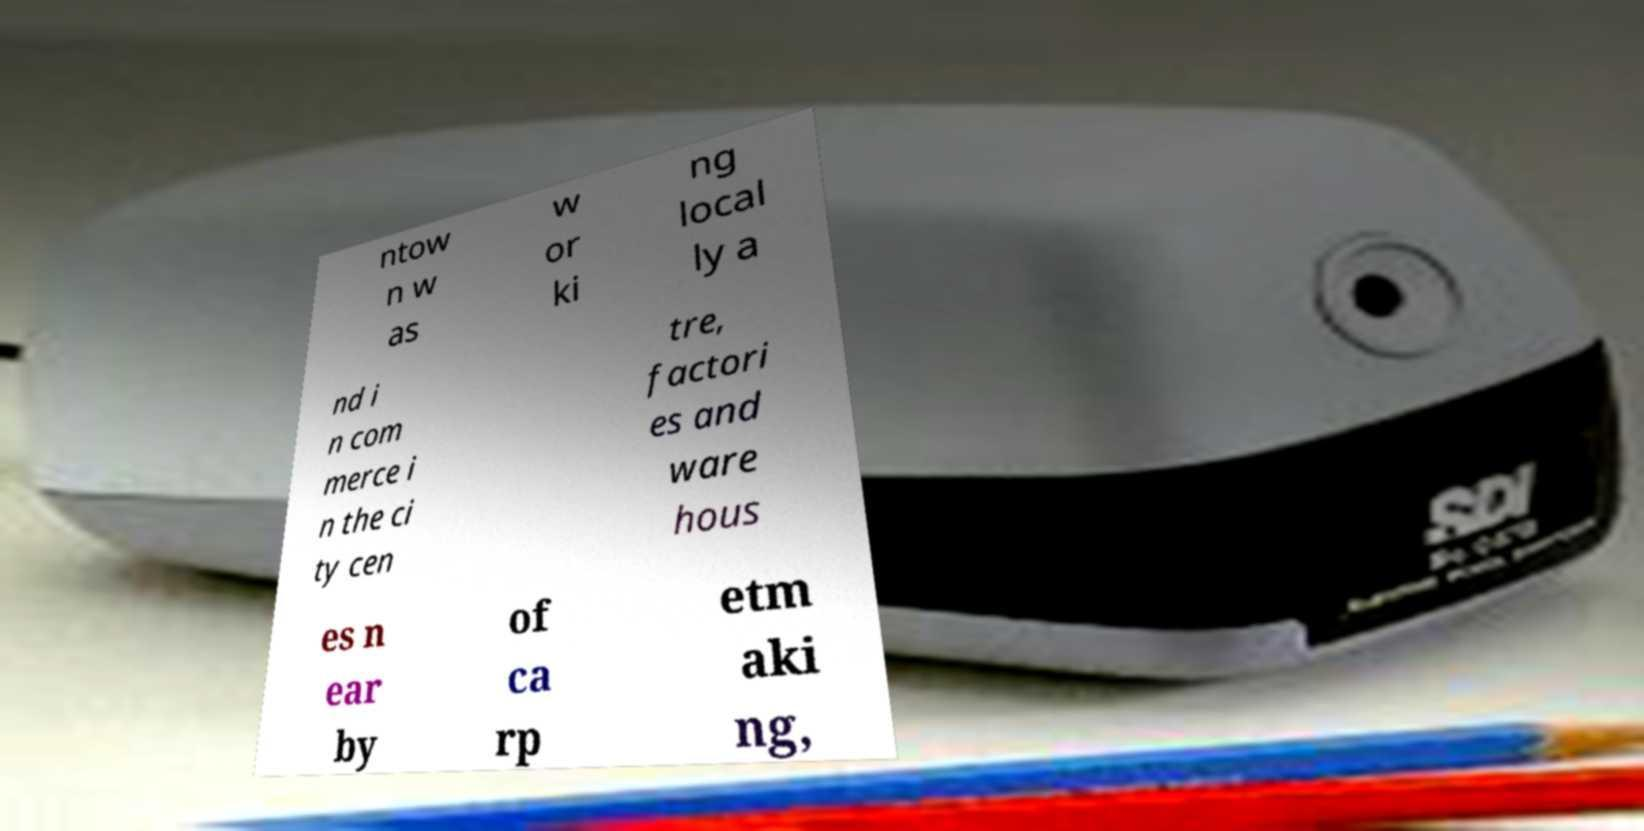Can you read and provide the text displayed in the image?This photo seems to have some interesting text. Can you extract and type it out for me? ntow n w as w or ki ng local ly a nd i n com merce i n the ci ty cen tre, factori es and ware hous es n ear by of ca rp etm aki ng, 